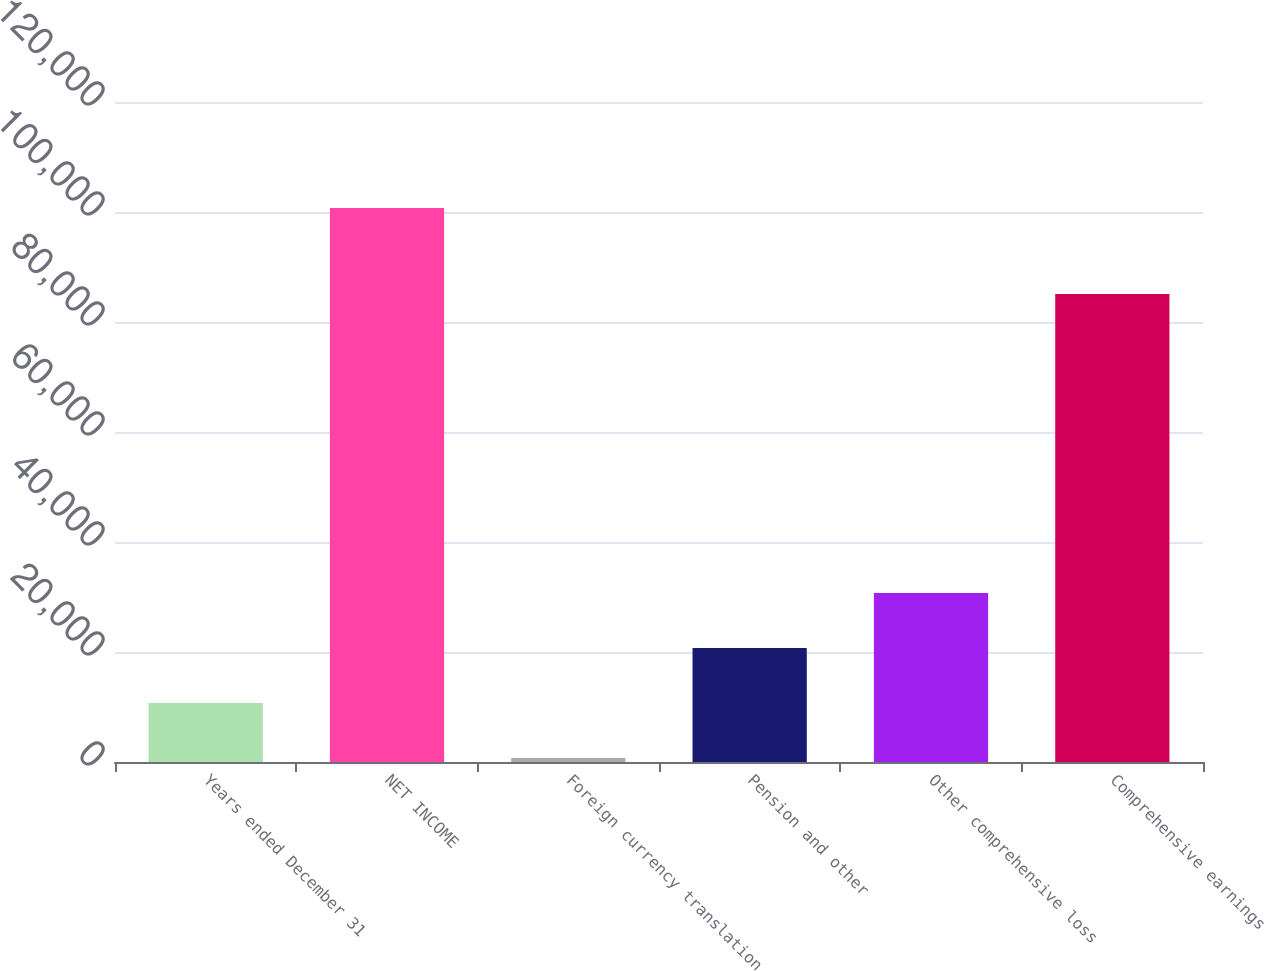Convert chart. <chart><loc_0><loc_0><loc_500><loc_500><bar_chart><fcel>Years ended December 31<fcel>NET INCOME<fcel>Foreign currency translation<fcel>Pension and other<fcel>Other comprehensive loss<fcel>Comprehensive earnings<nl><fcel>10708.3<fcel>100711<fcel>708<fcel>20708.6<fcel>30708.9<fcel>85111<nl></chart> 